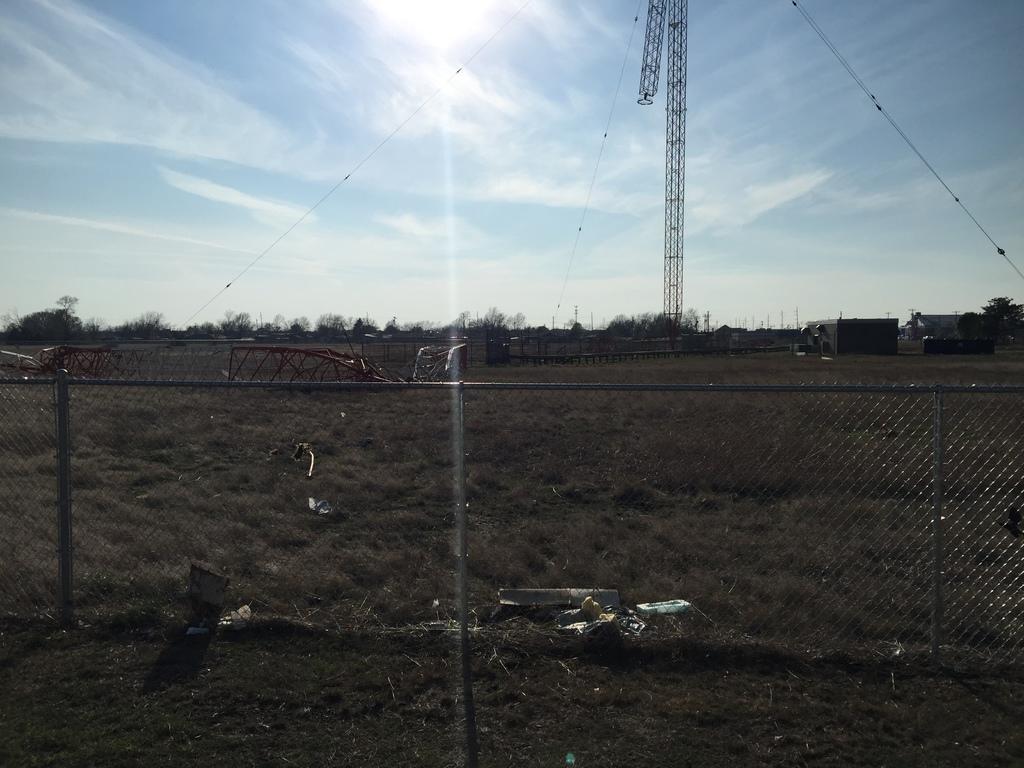How would you summarize this image in a sentence or two? In this image I can see a fence , through fence I can see grass and trees, stand , cable wires attached to the stand and the sky and sun light visible, there are some small tent house visible in the middle. 